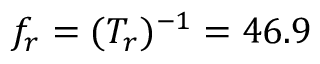<formula> <loc_0><loc_0><loc_500><loc_500>f _ { r } = ( T _ { r } ) ^ { - 1 } = 4 6 . 9</formula> 